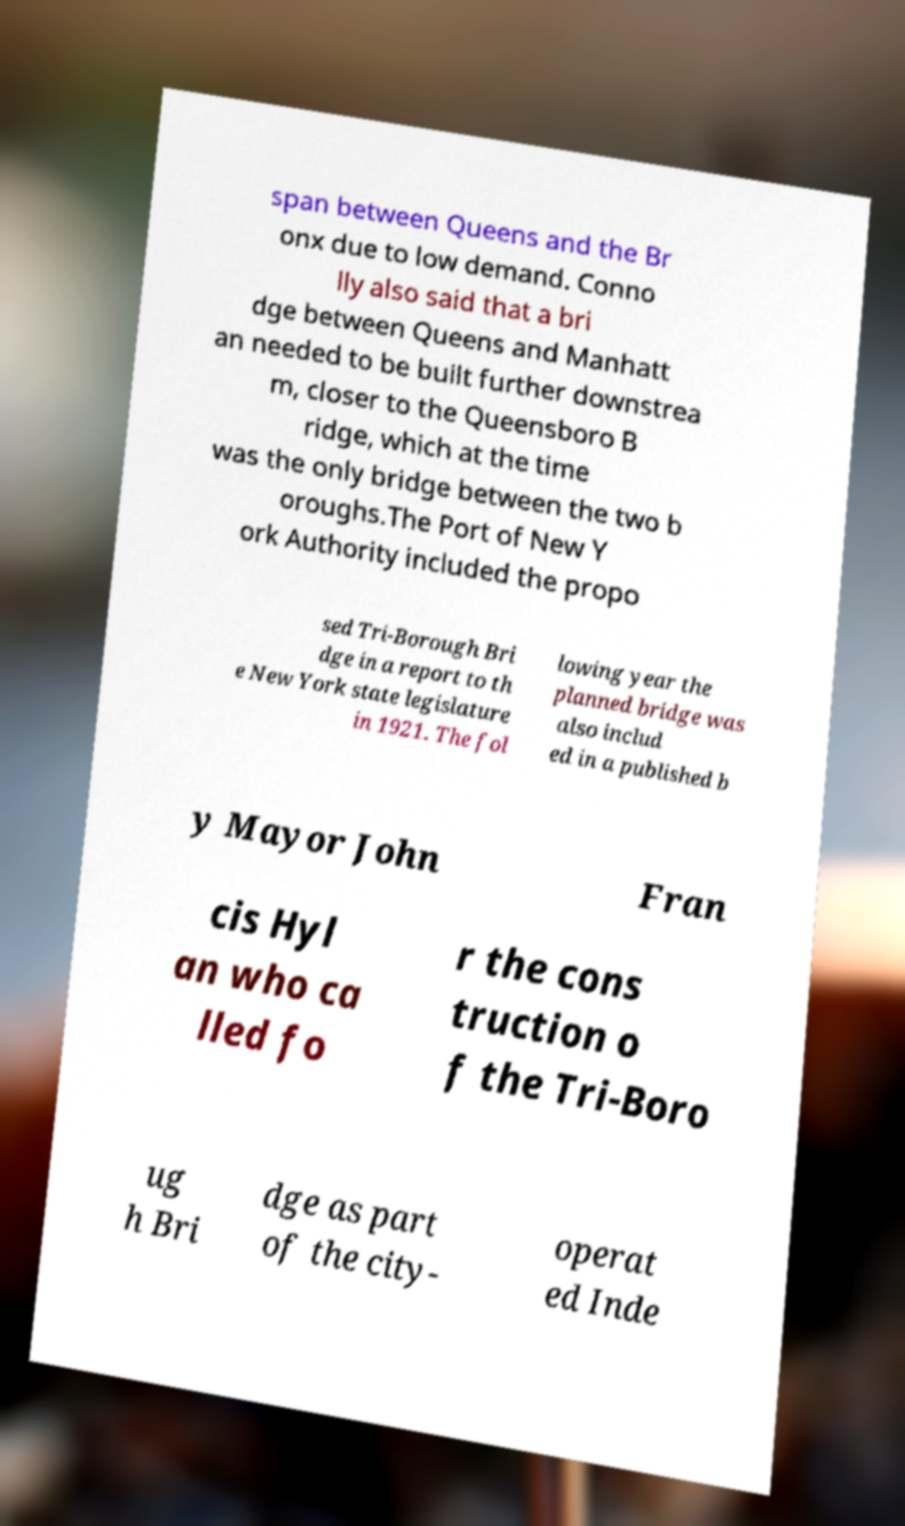For documentation purposes, I need the text within this image transcribed. Could you provide that? span between Queens and the Br onx due to low demand. Conno lly also said that a bri dge between Queens and Manhatt an needed to be built further downstrea m, closer to the Queensboro B ridge, which at the time was the only bridge between the two b oroughs.The Port of New Y ork Authority included the propo sed Tri-Borough Bri dge in a report to th e New York state legislature in 1921. The fol lowing year the planned bridge was also includ ed in a published b y Mayor John Fran cis Hyl an who ca lled fo r the cons truction o f the Tri-Boro ug h Bri dge as part of the city- operat ed Inde 